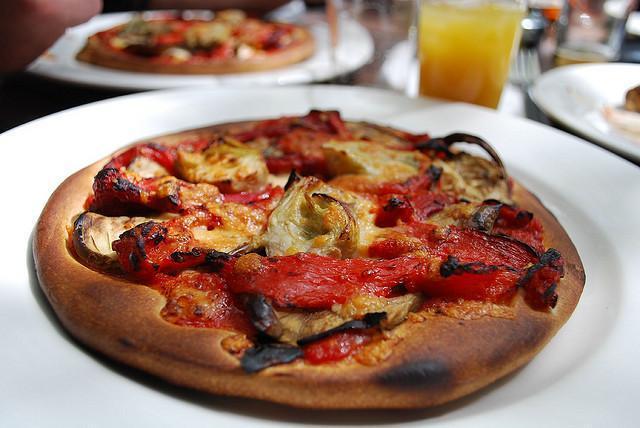How many pizzas are shown?
Give a very brief answer. 2. How many pizzas are there?
Give a very brief answer. 2. How many people can sleep in this room?
Give a very brief answer. 0. 